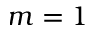Convert formula to latex. <formula><loc_0><loc_0><loc_500><loc_500>m = 1</formula> 